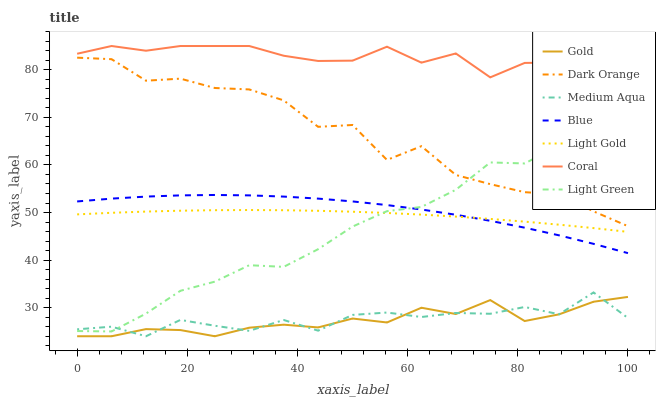Does Gold have the minimum area under the curve?
Answer yes or no. Yes. Does Coral have the maximum area under the curve?
Answer yes or no. Yes. Does Dark Orange have the minimum area under the curve?
Answer yes or no. No. Does Dark Orange have the maximum area under the curve?
Answer yes or no. No. Is Light Gold the smoothest?
Answer yes or no. Yes. Is Dark Orange the roughest?
Answer yes or no. Yes. Is Gold the smoothest?
Answer yes or no. No. Is Gold the roughest?
Answer yes or no. No. Does Gold have the lowest value?
Answer yes or no. Yes. Does Dark Orange have the lowest value?
Answer yes or no. No. Does Coral have the highest value?
Answer yes or no. Yes. Does Dark Orange have the highest value?
Answer yes or no. No. Is Medium Aqua less than Coral?
Answer yes or no. Yes. Is Blue greater than Medium Aqua?
Answer yes or no. Yes. Does Gold intersect Medium Aqua?
Answer yes or no. Yes. Is Gold less than Medium Aqua?
Answer yes or no. No. Is Gold greater than Medium Aqua?
Answer yes or no. No. Does Medium Aqua intersect Coral?
Answer yes or no. No. 